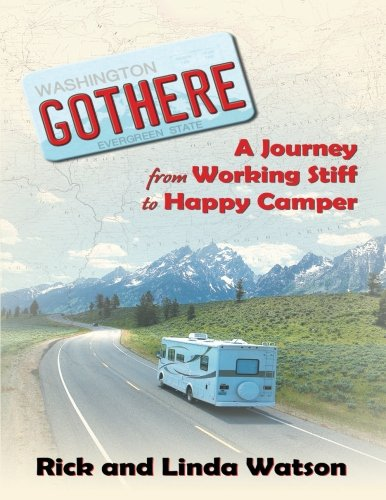What does the tagline on the book cover imply about the authors' journey? The tagline 'A Journey from Working Stiff to Happy Camper' implies that the authors' journey involves a transformative experience from a routine, possibly monotonous life to one filled with happiness and freedom, attained through traveling and exploring new environments. 